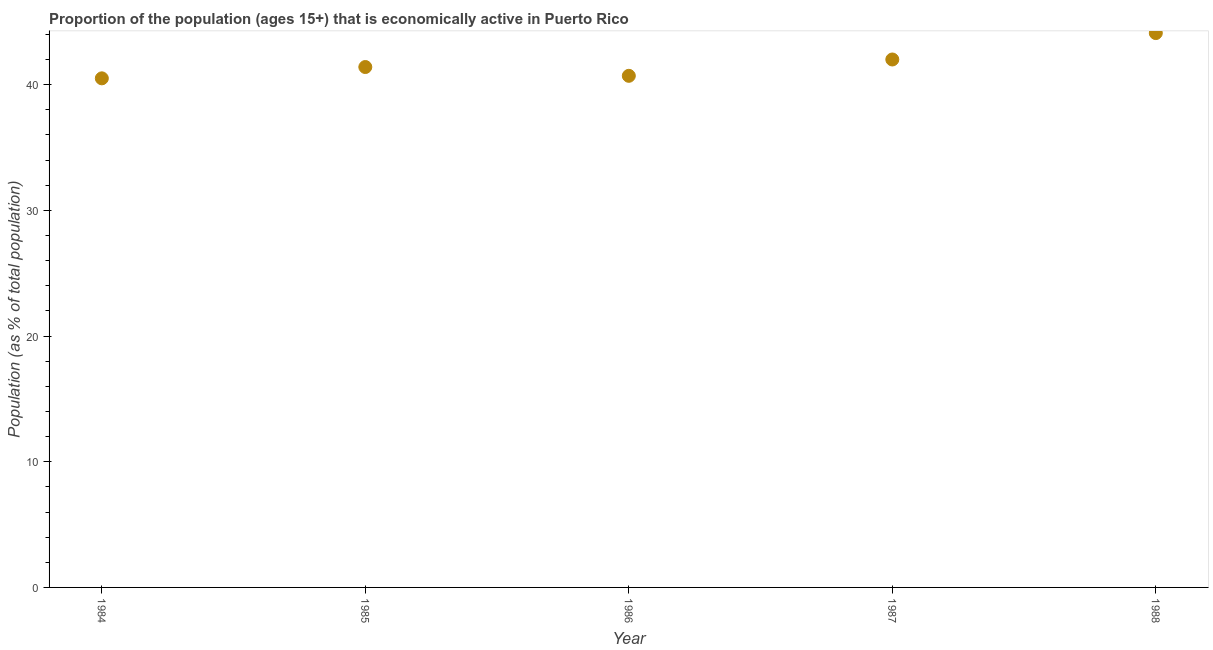What is the percentage of economically active population in 1984?
Give a very brief answer. 40.5. Across all years, what is the maximum percentage of economically active population?
Offer a very short reply. 44.1. Across all years, what is the minimum percentage of economically active population?
Your answer should be compact. 40.5. What is the sum of the percentage of economically active population?
Keep it short and to the point. 208.7. What is the difference between the percentage of economically active population in 1985 and 1988?
Provide a short and direct response. -2.7. What is the average percentage of economically active population per year?
Your answer should be compact. 41.74. What is the median percentage of economically active population?
Your answer should be very brief. 41.4. What is the ratio of the percentage of economically active population in 1984 to that in 1987?
Provide a short and direct response. 0.96. What is the difference between the highest and the second highest percentage of economically active population?
Ensure brevity in your answer.  2.1. What is the difference between the highest and the lowest percentage of economically active population?
Provide a short and direct response. 3.6. How many years are there in the graph?
Your answer should be compact. 5. What is the difference between two consecutive major ticks on the Y-axis?
Your answer should be compact. 10. Are the values on the major ticks of Y-axis written in scientific E-notation?
Provide a short and direct response. No. What is the title of the graph?
Provide a short and direct response. Proportion of the population (ages 15+) that is economically active in Puerto Rico. What is the label or title of the Y-axis?
Offer a terse response. Population (as % of total population). What is the Population (as % of total population) in 1984?
Keep it short and to the point. 40.5. What is the Population (as % of total population) in 1985?
Your response must be concise. 41.4. What is the Population (as % of total population) in 1986?
Provide a short and direct response. 40.7. What is the Population (as % of total population) in 1987?
Provide a short and direct response. 42. What is the Population (as % of total population) in 1988?
Your answer should be very brief. 44.1. What is the difference between the Population (as % of total population) in 1984 and 1985?
Ensure brevity in your answer.  -0.9. What is the difference between the Population (as % of total population) in 1984 and 1986?
Your response must be concise. -0.2. What is the difference between the Population (as % of total population) in 1984 and 1987?
Give a very brief answer. -1.5. What is the difference between the Population (as % of total population) in 1984 and 1988?
Your answer should be compact. -3.6. What is the difference between the Population (as % of total population) in 1985 and 1986?
Make the answer very short. 0.7. What is the difference between the Population (as % of total population) in 1985 and 1987?
Provide a succinct answer. -0.6. What is the difference between the Population (as % of total population) in 1986 and 1987?
Provide a short and direct response. -1.3. What is the ratio of the Population (as % of total population) in 1984 to that in 1986?
Keep it short and to the point. 0.99. What is the ratio of the Population (as % of total population) in 1984 to that in 1988?
Make the answer very short. 0.92. What is the ratio of the Population (as % of total population) in 1985 to that in 1988?
Ensure brevity in your answer.  0.94. What is the ratio of the Population (as % of total population) in 1986 to that in 1988?
Ensure brevity in your answer.  0.92. What is the ratio of the Population (as % of total population) in 1987 to that in 1988?
Your answer should be compact. 0.95. 